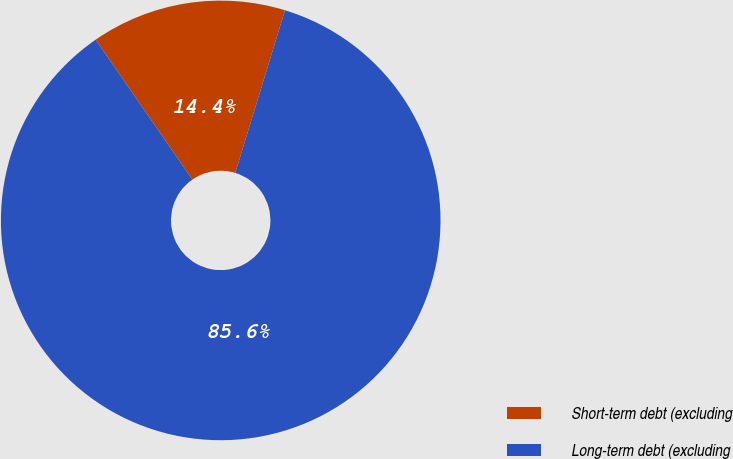<chart> <loc_0><loc_0><loc_500><loc_500><pie_chart><fcel>Short-term debt (excluding<fcel>Long-term debt (excluding<nl><fcel>14.36%<fcel>85.64%<nl></chart> 